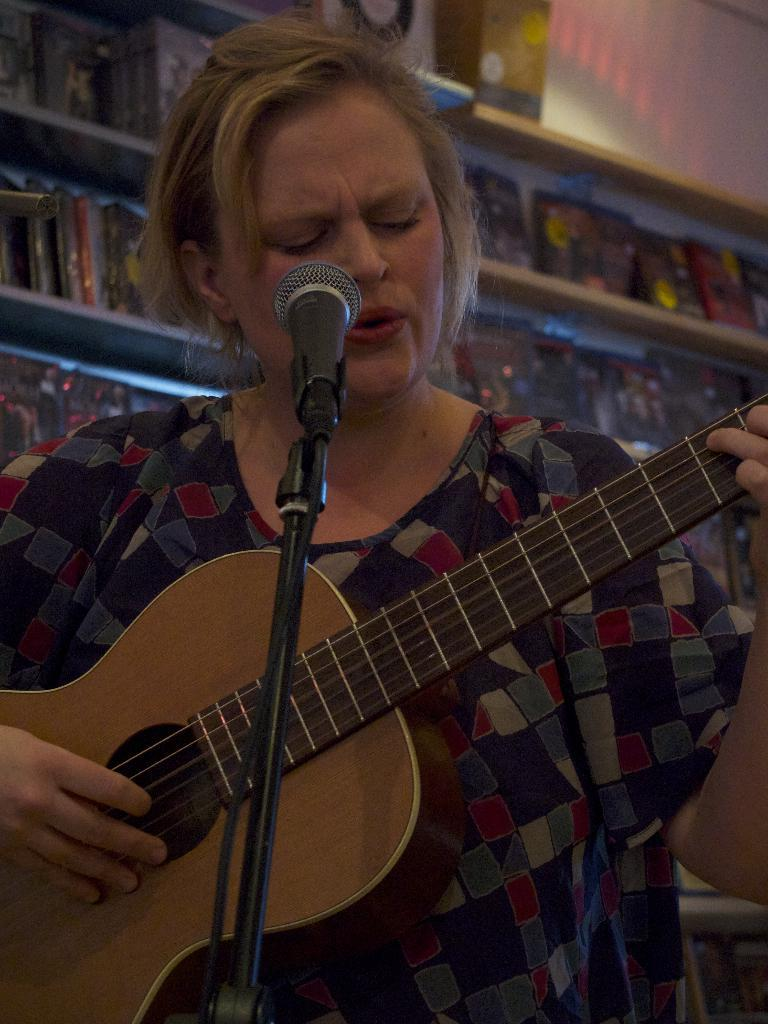Who is the main subject in the image? There is a woman in the image. What is the woman doing in the image? The woman is playing a guitar. What object is in front of the woman? The woman is in front of a microphone. What can be seen in the background of the image? There are racks visible in the background of the image. What type of committee is visible in the image? There is no committee present in the image; it features a woman playing a guitar in front of a microphone with racks visible in the background. 